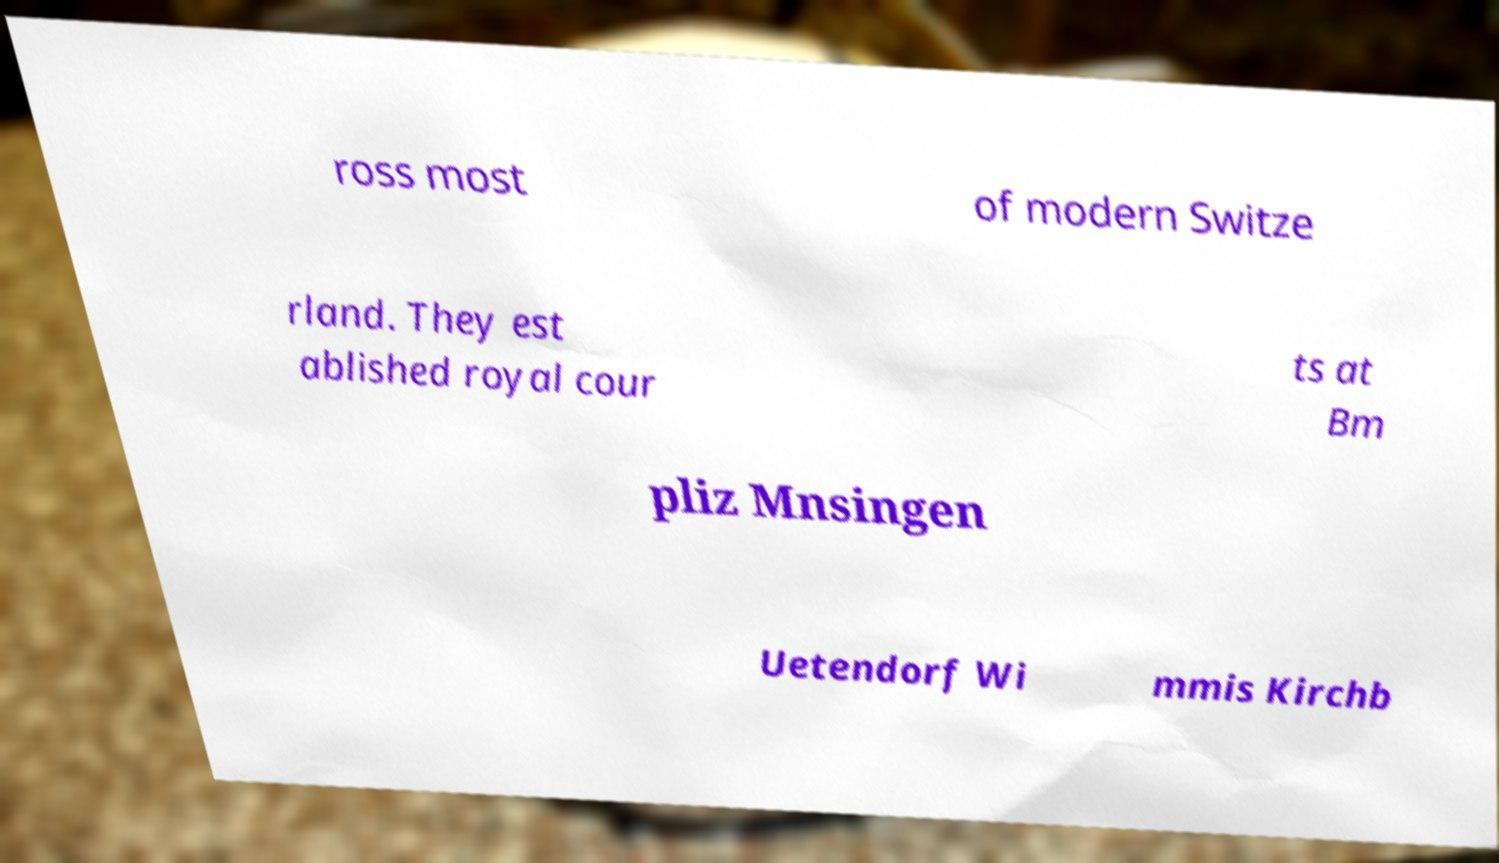Please identify and transcribe the text found in this image. ross most of modern Switze rland. They est ablished royal cour ts at Bm pliz Mnsingen Uetendorf Wi mmis Kirchb 